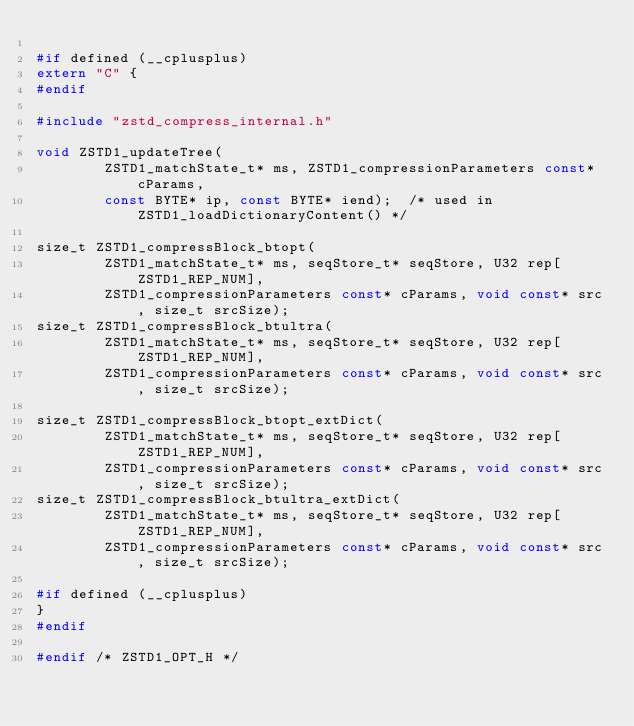<code> <loc_0><loc_0><loc_500><loc_500><_C_>
#if defined (__cplusplus)
extern "C" {
#endif

#include "zstd_compress_internal.h"

void ZSTD1_updateTree(
        ZSTD1_matchState_t* ms, ZSTD1_compressionParameters const* cParams,
        const BYTE* ip, const BYTE* iend);  /* used in ZSTD1_loadDictionaryContent() */

size_t ZSTD1_compressBlock_btopt(
        ZSTD1_matchState_t* ms, seqStore_t* seqStore, U32 rep[ZSTD1_REP_NUM],
        ZSTD1_compressionParameters const* cParams, void const* src, size_t srcSize);
size_t ZSTD1_compressBlock_btultra(
        ZSTD1_matchState_t* ms, seqStore_t* seqStore, U32 rep[ZSTD1_REP_NUM],
        ZSTD1_compressionParameters const* cParams, void const* src, size_t srcSize);

size_t ZSTD1_compressBlock_btopt_extDict(
        ZSTD1_matchState_t* ms, seqStore_t* seqStore, U32 rep[ZSTD1_REP_NUM],
        ZSTD1_compressionParameters const* cParams, void const* src, size_t srcSize);
size_t ZSTD1_compressBlock_btultra_extDict(
        ZSTD1_matchState_t* ms, seqStore_t* seqStore, U32 rep[ZSTD1_REP_NUM],
        ZSTD1_compressionParameters const* cParams, void const* src, size_t srcSize);

#if defined (__cplusplus)
}
#endif

#endif /* ZSTD1_OPT_H */
</code> 